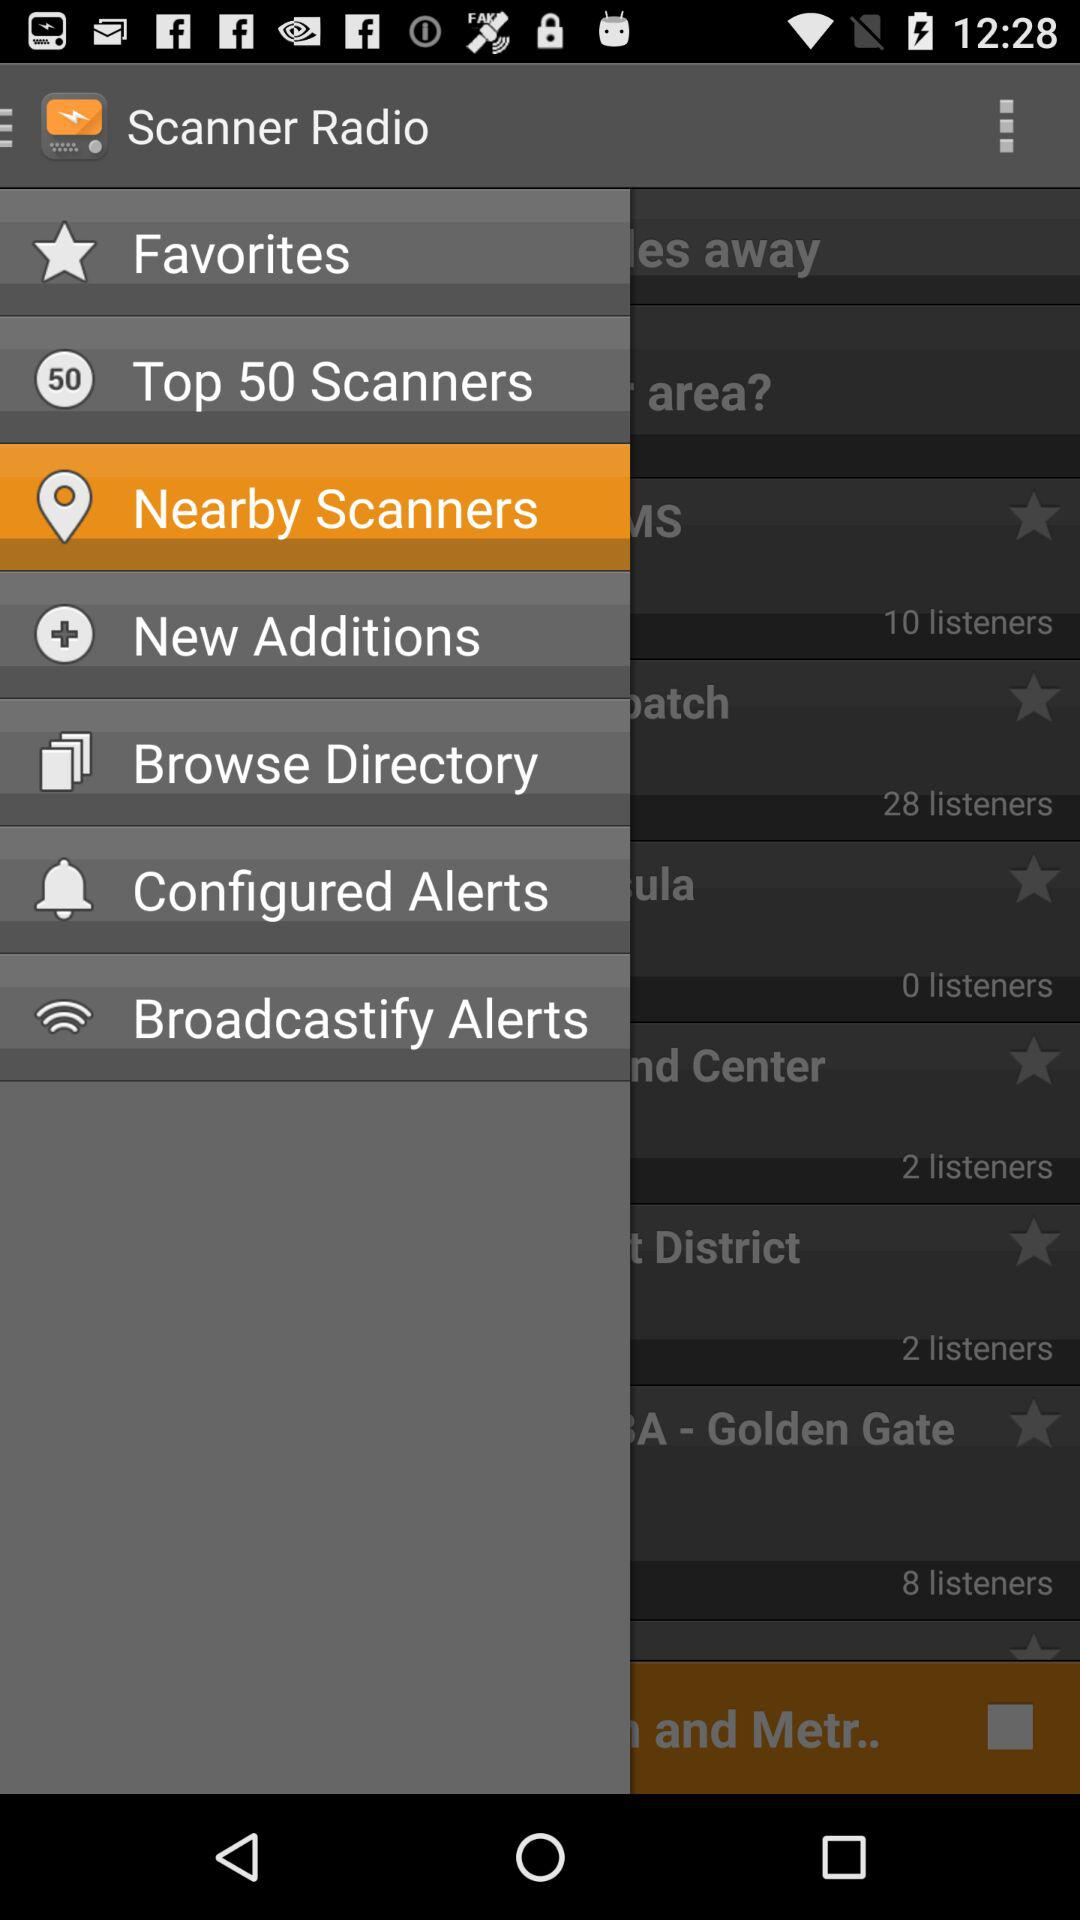What is the application name? The application name is "Scanner Radio". 